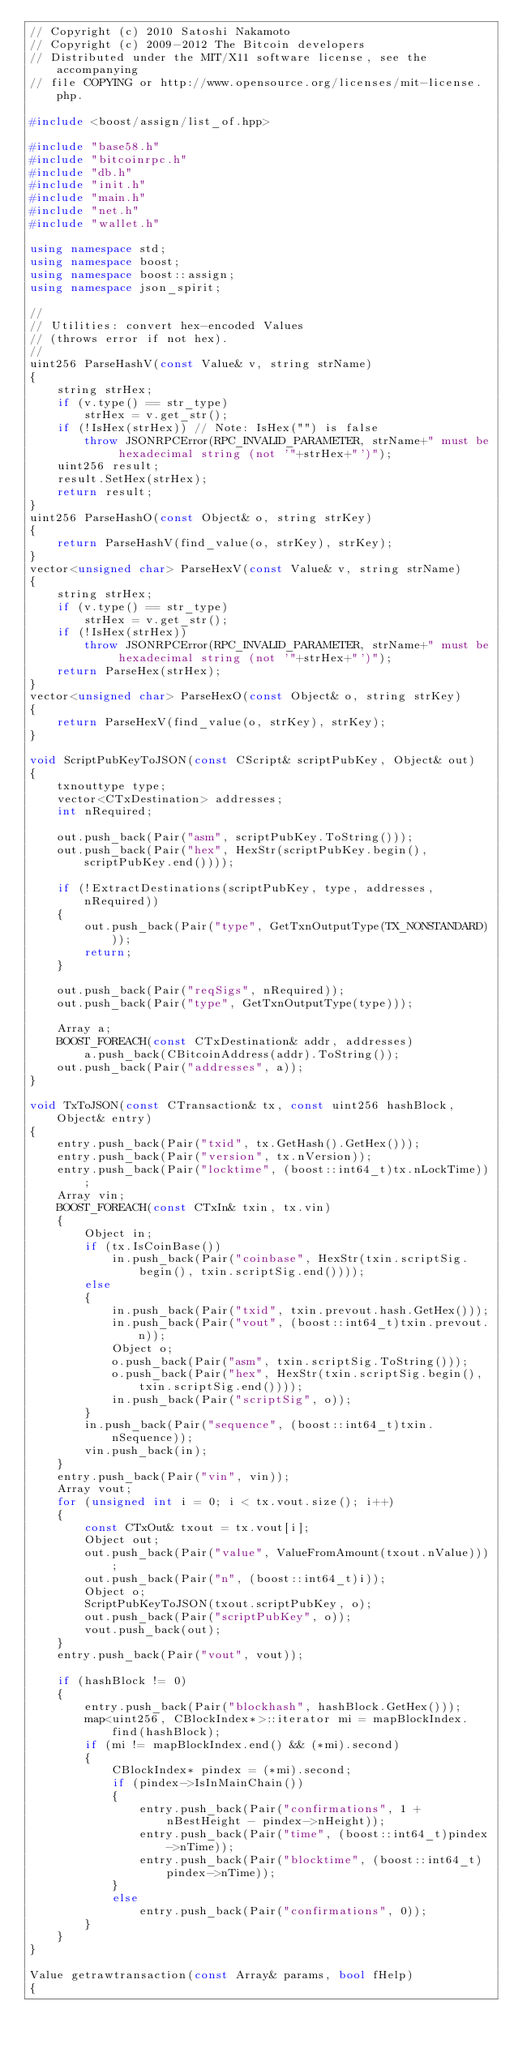<code> <loc_0><loc_0><loc_500><loc_500><_C++_>// Copyright (c) 2010 Satoshi Nakamoto
// Copyright (c) 2009-2012 The Bitcoin developers
// Distributed under the MIT/X11 software license, see the accompanying
// file COPYING or http://www.opensource.org/licenses/mit-license.php.

#include <boost/assign/list_of.hpp>

#include "base58.h"
#include "bitcoinrpc.h"
#include "db.h"
#include "init.h"
#include "main.h"
#include "net.h"
#include "wallet.h"

using namespace std;
using namespace boost;
using namespace boost::assign;
using namespace json_spirit;

//
// Utilities: convert hex-encoded Values
// (throws error if not hex).
//
uint256 ParseHashV(const Value& v, string strName)
{
    string strHex;
    if (v.type() == str_type)
        strHex = v.get_str();
    if (!IsHex(strHex)) // Note: IsHex("") is false
        throw JSONRPCError(RPC_INVALID_PARAMETER, strName+" must be hexadecimal string (not '"+strHex+"')");
    uint256 result;
    result.SetHex(strHex);
    return result;
}
uint256 ParseHashO(const Object& o, string strKey)
{
    return ParseHashV(find_value(o, strKey), strKey);
}
vector<unsigned char> ParseHexV(const Value& v, string strName)
{
    string strHex;
    if (v.type() == str_type)
        strHex = v.get_str();
    if (!IsHex(strHex))
        throw JSONRPCError(RPC_INVALID_PARAMETER, strName+" must be hexadecimal string (not '"+strHex+"')");
    return ParseHex(strHex);
}
vector<unsigned char> ParseHexO(const Object& o, string strKey)
{
    return ParseHexV(find_value(o, strKey), strKey);
}

void ScriptPubKeyToJSON(const CScript& scriptPubKey, Object& out)
{
    txnouttype type;
    vector<CTxDestination> addresses;
    int nRequired;

    out.push_back(Pair("asm", scriptPubKey.ToString()));
    out.push_back(Pair("hex", HexStr(scriptPubKey.begin(), scriptPubKey.end())));

    if (!ExtractDestinations(scriptPubKey, type, addresses, nRequired))
    {
        out.push_back(Pair("type", GetTxnOutputType(TX_NONSTANDARD)));
        return;
    }

    out.push_back(Pair("reqSigs", nRequired));
    out.push_back(Pair("type", GetTxnOutputType(type)));

    Array a;
    BOOST_FOREACH(const CTxDestination& addr, addresses)
        a.push_back(CBitcoinAddress(addr).ToString());
    out.push_back(Pair("addresses", a));
}

void TxToJSON(const CTransaction& tx, const uint256 hashBlock, Object& entry)
{
    entry.push_back(Pair("txid", tx.GetHash().GetHex()));
    entry.push_back(Pair("version", tx.nVersion));
    entry.push_back(Pair("locktime", (boost::int64_t)tx.nLockTime));
    Array vin;
    BOOST_FOREACH(const CTxIn& txin, tx.vin)
    {
        Object in;
        if (tx.IsCoinBase())
            in.push_back(Pair("coinbase", HexStr(txin.scriptSig.begin(), txin.scriptSig.end())));
        else
        {
            in.push_back(Pair("txid", txin.prevout.hash.GetHex()));
            in.push_back(Pair("vout", (boost::int64_t)txin.prevout.n));
            Object o;
            o.push_back(Pair("asm", txin.scriptSig.ToString()));
            o.push_back(Pair("hex", HexStr(txin.scriptSig.begin(), txin.scriptSig.end())));
            in.push_back(Pair("scriptSig", o));
        }
        in.push_back(Pair("sequence", (boost::int64_t)txin.nSequence));
        vin.push_back(in);
    }
    entry.push_back(Pair("vin", vin));
    Array vout;
    for (unsigned int i = 0; i < tx.vout.size(); i++)
    {
        const CTxOut& txout = tx.vout[i];
        Object out;
        out.push_back(Pair("value", ValueFromAmount(txout.nValue)));
        out.push_back(Pair("n", (boost::int64_t)i));
        Object o;
        ScriptPubKeyToJSON(txout.scriptPubKey, o);
        out.push_back(Pair("scriptPubKey", o));
        vout.push_back(out);
    }
    entry.push_back(Pair("vout", vout));

    if (hashBlock != 0)
    {
        entry.push_back(Pair("blockhash", hashBlock.GetHex()));
        map<uint256, CBlockIndex*>::iterator mi = mapBlockIndex.find(hashBlock);
        if (mi != mapBlockIndex.end() && (*mi).second)
        {
            CBlockIndex* pindex = (*mi).second;
            if (pindex->IsInMainChain())
            {
                entry.push_back(Pair("confirmations", 1 + nBestHeight - pindex->nHeight));
                entry.push_back(Pair("time", (boost::int64_t)pindex->nTime));
                entry.push_back(Pair("blocktime", (boost::int64_t)pindex->nTime));
            }
            else
                entry.push_back(Pair("confirmations", 0));
        }
    }
}

Value getrawtransaction(const Array& params, bool fHelp)
{</code> 